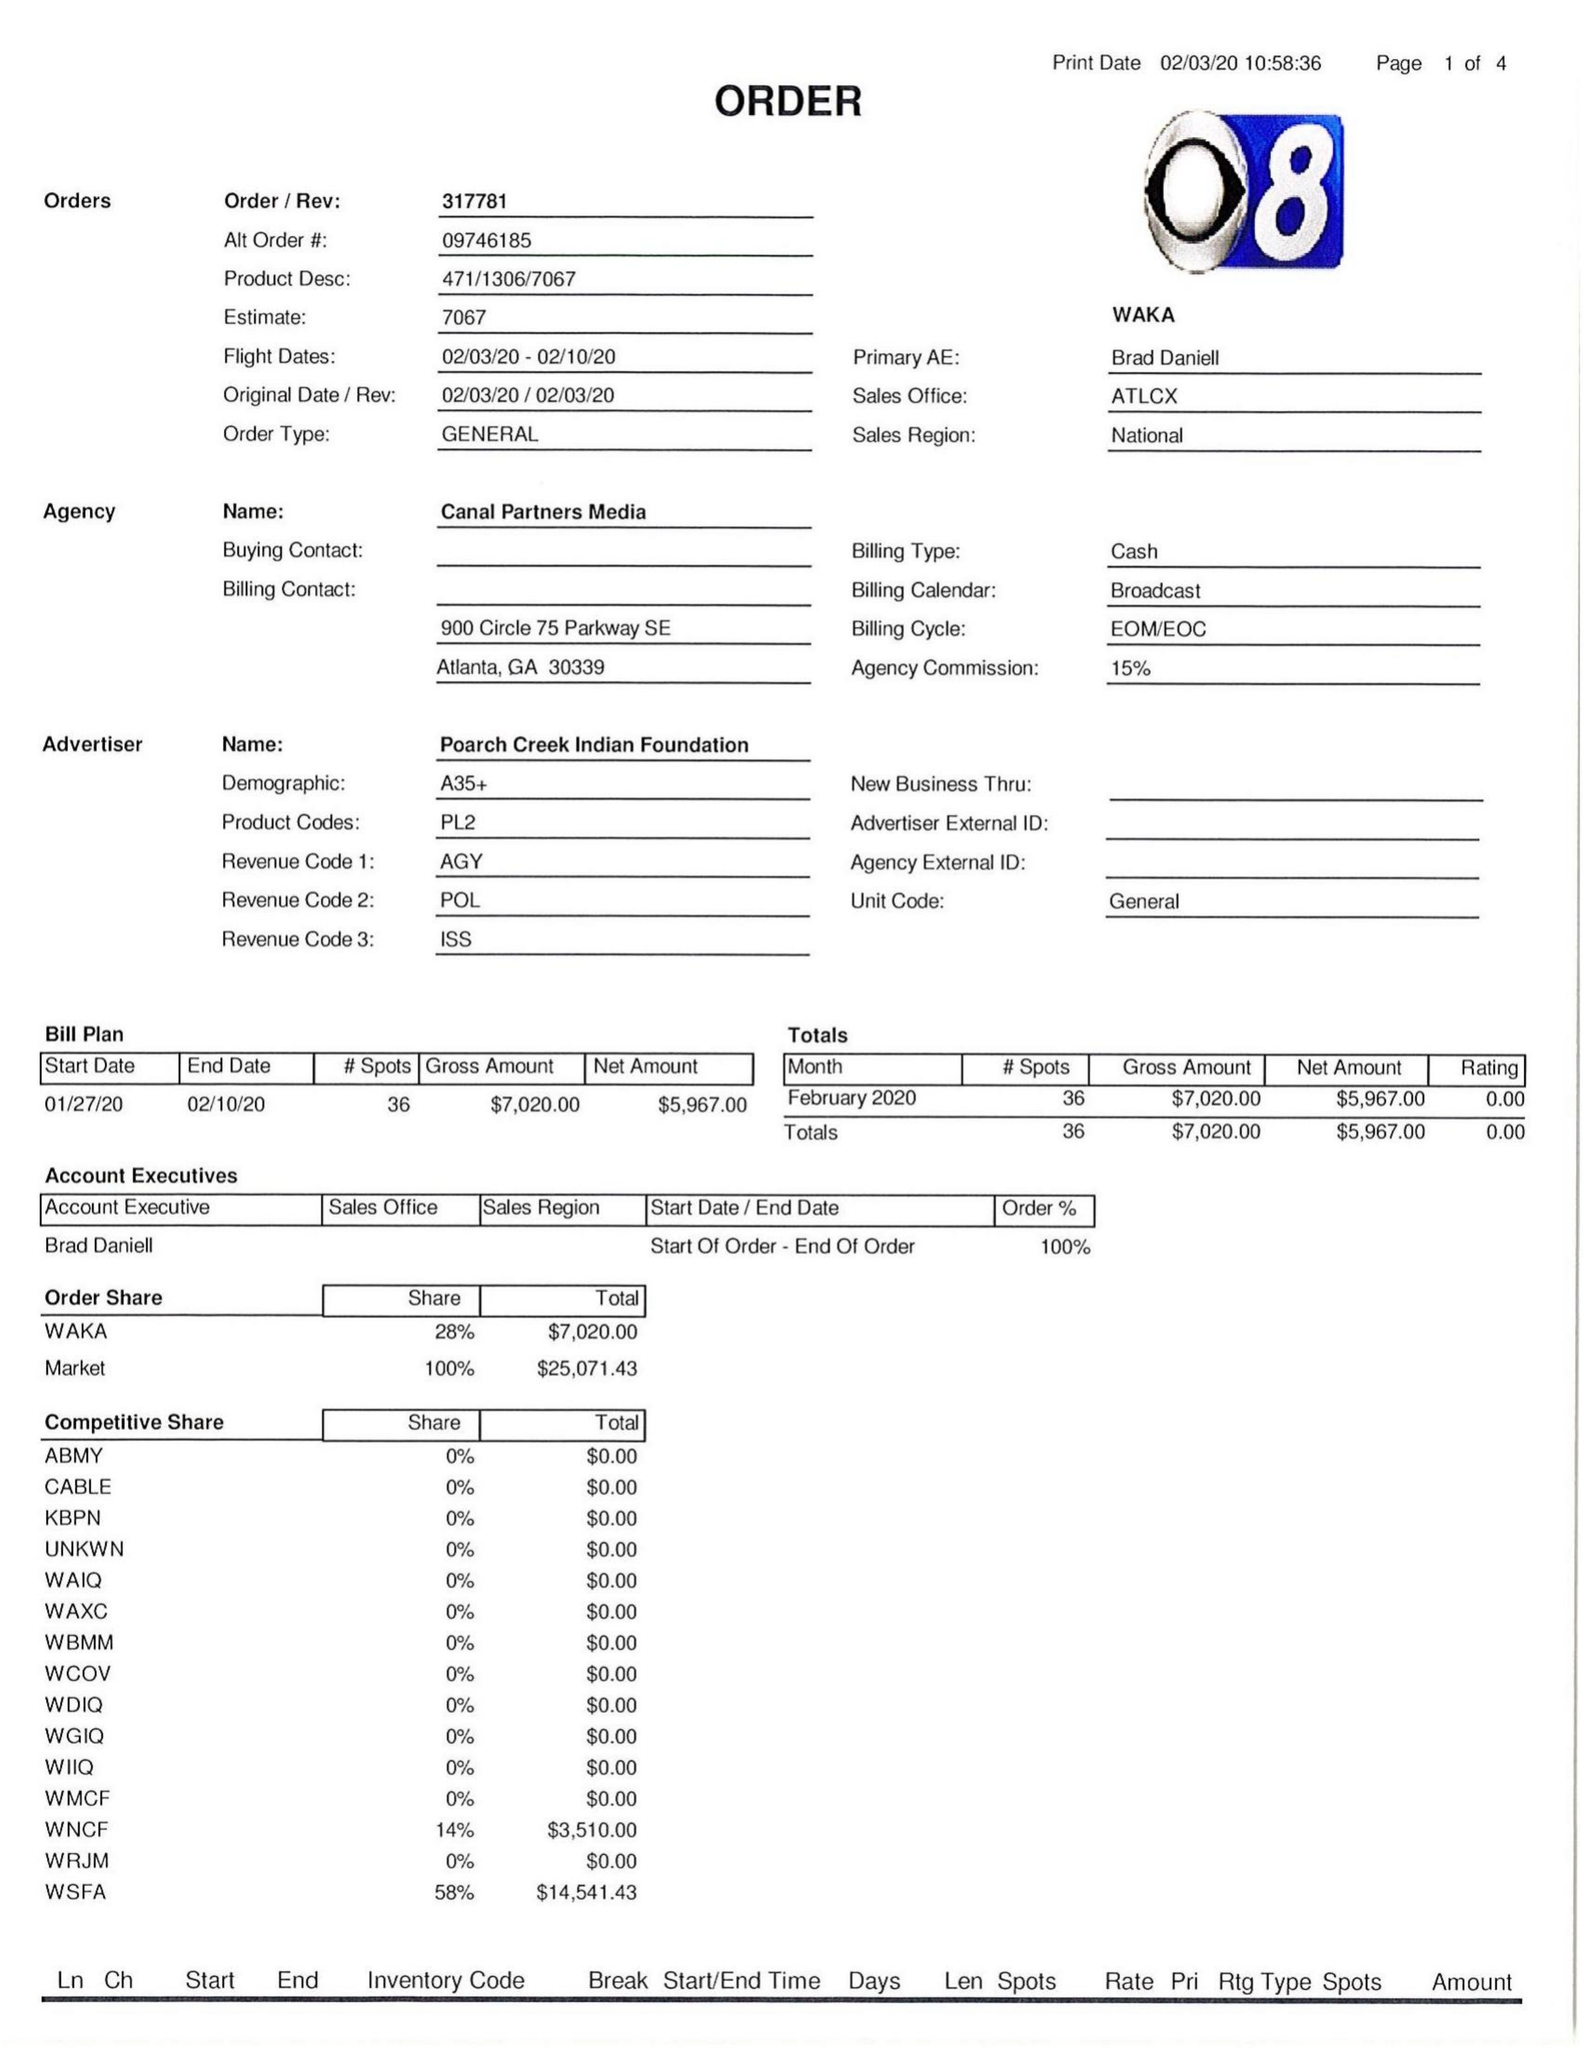What is the value for the flight_from?
Answer the question using a single word or phrase. 02/03/20 